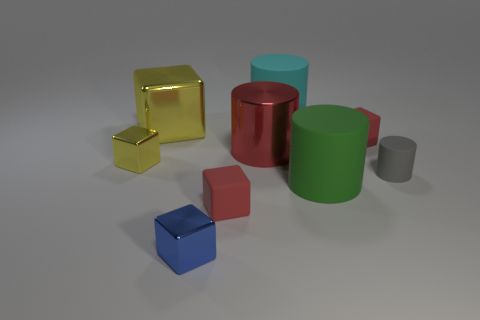There is a small object that is on the right side of the small blue metal cube and in front of the green matte thing; what is its color?
Give a very brief answer. Red. There is a blue block; is its size the same as the red thing that is in front of the small yellow thing?
Make the answer very short. Yes. What is the shape of the red matte thing behind the red metallic object?
Your response must be concise. Cube. Is there anything else that is the same material as the big red object?
Offer a terse response. Yes. Is the number of small metal cubes right of the big cyan matte thing greater than the number of large green objects?
Offer a terse response. No. There is a small red matte object that is in front of the red object to the right of the big green cylinder; how many yellow things are right of it?
Your answer should be very brief. 0. There is a yellow thing that is in front of the red cylinder; is it the same size as the red rubber block that is on the right side of the big cyan object?
Your answer should be very brief. Yes. What material is the yellow object behind the small red matte thing that is behind the tiny yellow shiny object made of?
Offer a terse response. Metal. How many things are either objects that are right of the large yellow metallic thing or yellow metallic objects?
Your response must be concise. 9. Are there an equal number of large yellow metallic objects that are in front of the tiny blue thing and small things that are in front of the tiny yellow block?
Your answer should be very brief. No. 